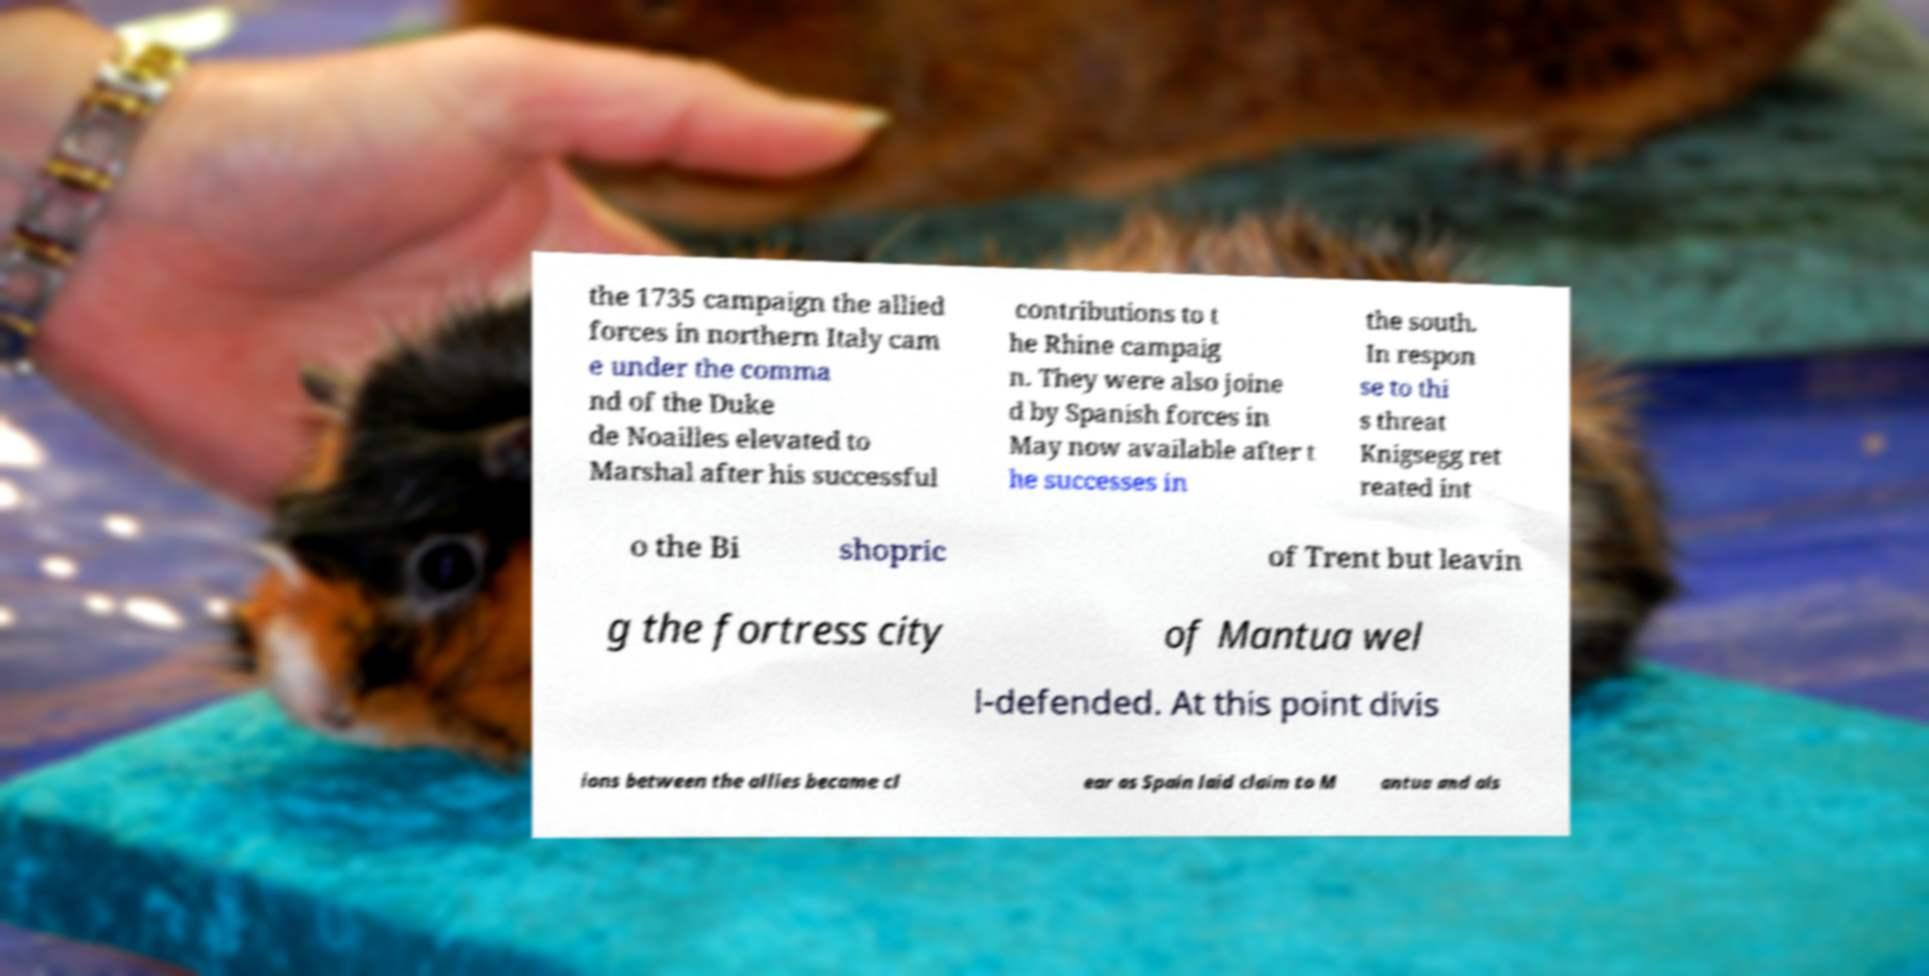Please identify and transcribe the text found in this image. the 1735 campaign the allied forces in northern Italy cam e under the comma nd of the Duke de Noailles elevated to Marshal after his successful contributions to t he Rhine campaig n. They were also joine d by Spanish forces in May now available after t he successes in the south. In respon se to thi s threat Knigsegg ret reated int o the Bi shopric of Trent but leavin g the fortress city of Mantua wel l-defended. At this point divis ions between the allies became cl ear as Spain laid claim to M antua and als 